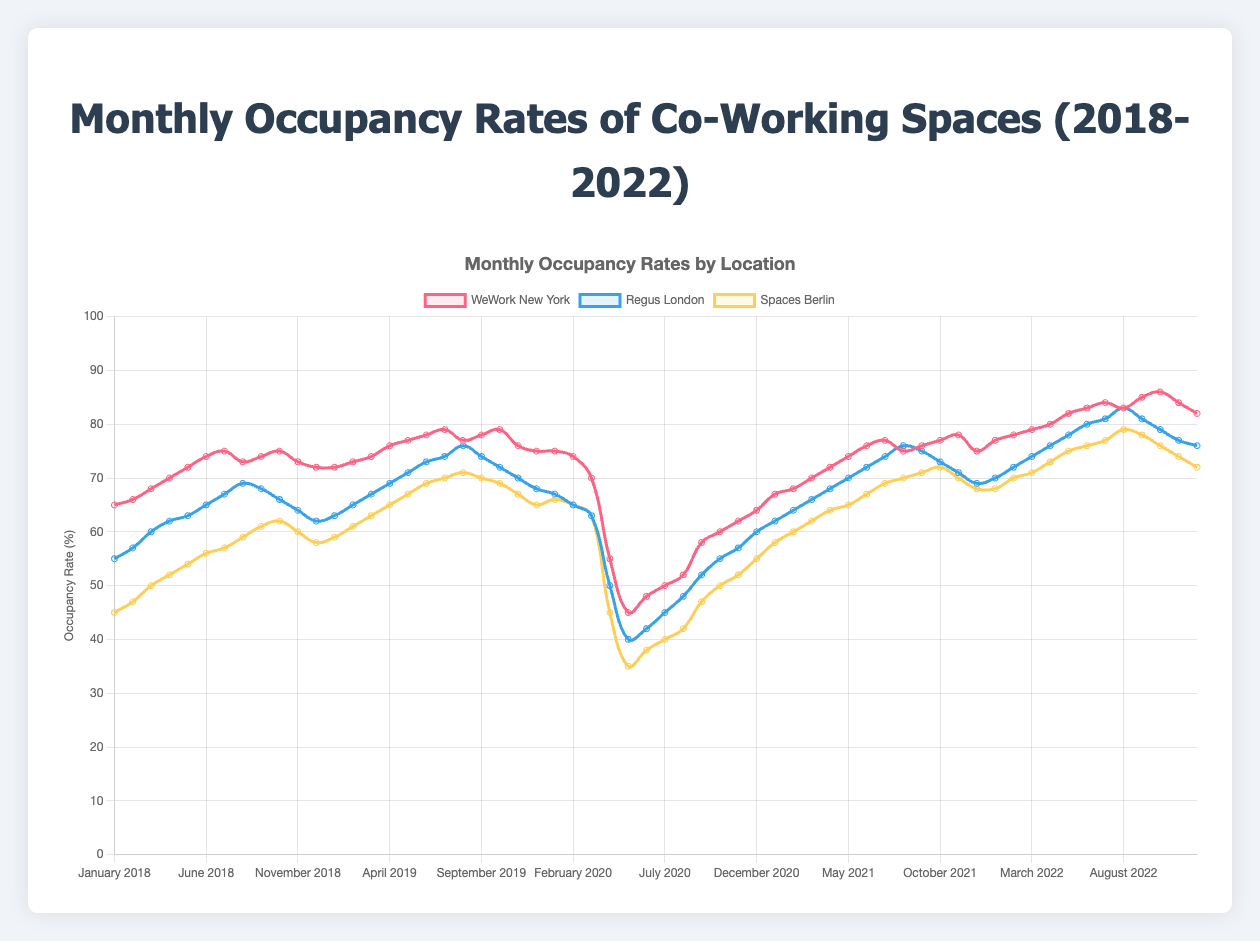Which location had the highest occupancy rate in December 2022? Look at the line colors for each location in December 2022. The WeWork New York line is at 82%, Regus London is at 76%, and Spaces Berlin is at 72%. Therefore, WeWork New York had the highest rate in December 2022.
Answer: WeWork New York During which year did the occupancy rate for Spaces Berlin hit its lowest point, and what was the value? Examine the line for Spaces Berlin over all years. The sharpest drop is in 2020 during May when the rate is 35%.
Answer: 2020, 35% Which month in 2019 had the lowest occupancy rate for WeWork New York? Track the WeWork New York line in 2019. November shows a drop to 76%, which is the lowest for that year.
Answer: November How did the average occupancy rate of Regus London in 2020 compare to that in 2019? First calculate the average for each year:
2019: (63+65+67+69+71+73+74+76+74+72+70+68)/12 ≈ 70.0
2020: (67+65+63+50+40+42+45+48+52+55+57+60)/12 ≈ 53.3
Now, subtract the average of 2020 from that of 2019: 70.0 - 53.3 = 16.7.
Answer: 16.7 points less in 2020 Which quarter of 2022 shows the greatest increase in occupancy rate for WeWork New York compared to the same quarter in 2021? Compute percentage increase for each quarter:
Q1: ((77+78+79) - (67+68+70)) / (67+68+70)/3 ≈ (234 - 205) / 205 ≈ 0.141 ≈ 14.1%
Q2: ((80+82+83) - (72+74+76)) / (72+74+76)/3 ≈ (245 - 222) / 222 ≈ 0.103 ≈ 10.3%
Q3: ((84+83+85) - (76+77+75)) / (76+77+75)/3 ≈ (252 - 228) / 228 ≈ 0.107 ≈ 10.7%
Q4: ((86+84+82) - (77+78+75)) / (77+78+75)/3 ≈ (252 - 230) / 230 ≈ 0.096 ≈ 9.6%
So, Q1 shows the greatest increase of 14.1%.
Answer: Q1 Which location experienced the most significant recovery in occupancy rate after the drop observed in 2020? Compare trends for each location post-2020:
WeWork New York: Dec 2020 to Dec 2021 from 64% to 75% = +11
Regus London: Dec 2020 to Dec 2021 from 60% to 69% = +9
Spaces Berlin: Dec 2020 to Dec 2021 from 55% to 68% = +13
Spaces Berlin had the highest increase of 13 points.
Answer: Spaces Berlin In which month of 2018 did WeWork New York reach 75% occupancy for the first time? Look at the line for WeWork New York in 2018. July is the first month with an occupancy rate of 75%.
Answer: July Which location had the steepest decline from its highest to lowest monthly occupancy rate in 2020? Calculate the differences for each location in 2020:
WeWork New York: 75% (Jan) to 45% (May) = −30%
Regus London: 67% (Jan) to 40% (May) = −27%
Spaces Berlin: 66% (Jan) to 35% (May) = -31%
Spaces Berlin had the largest decline of 31%.
Answer: Spaces Berlin 